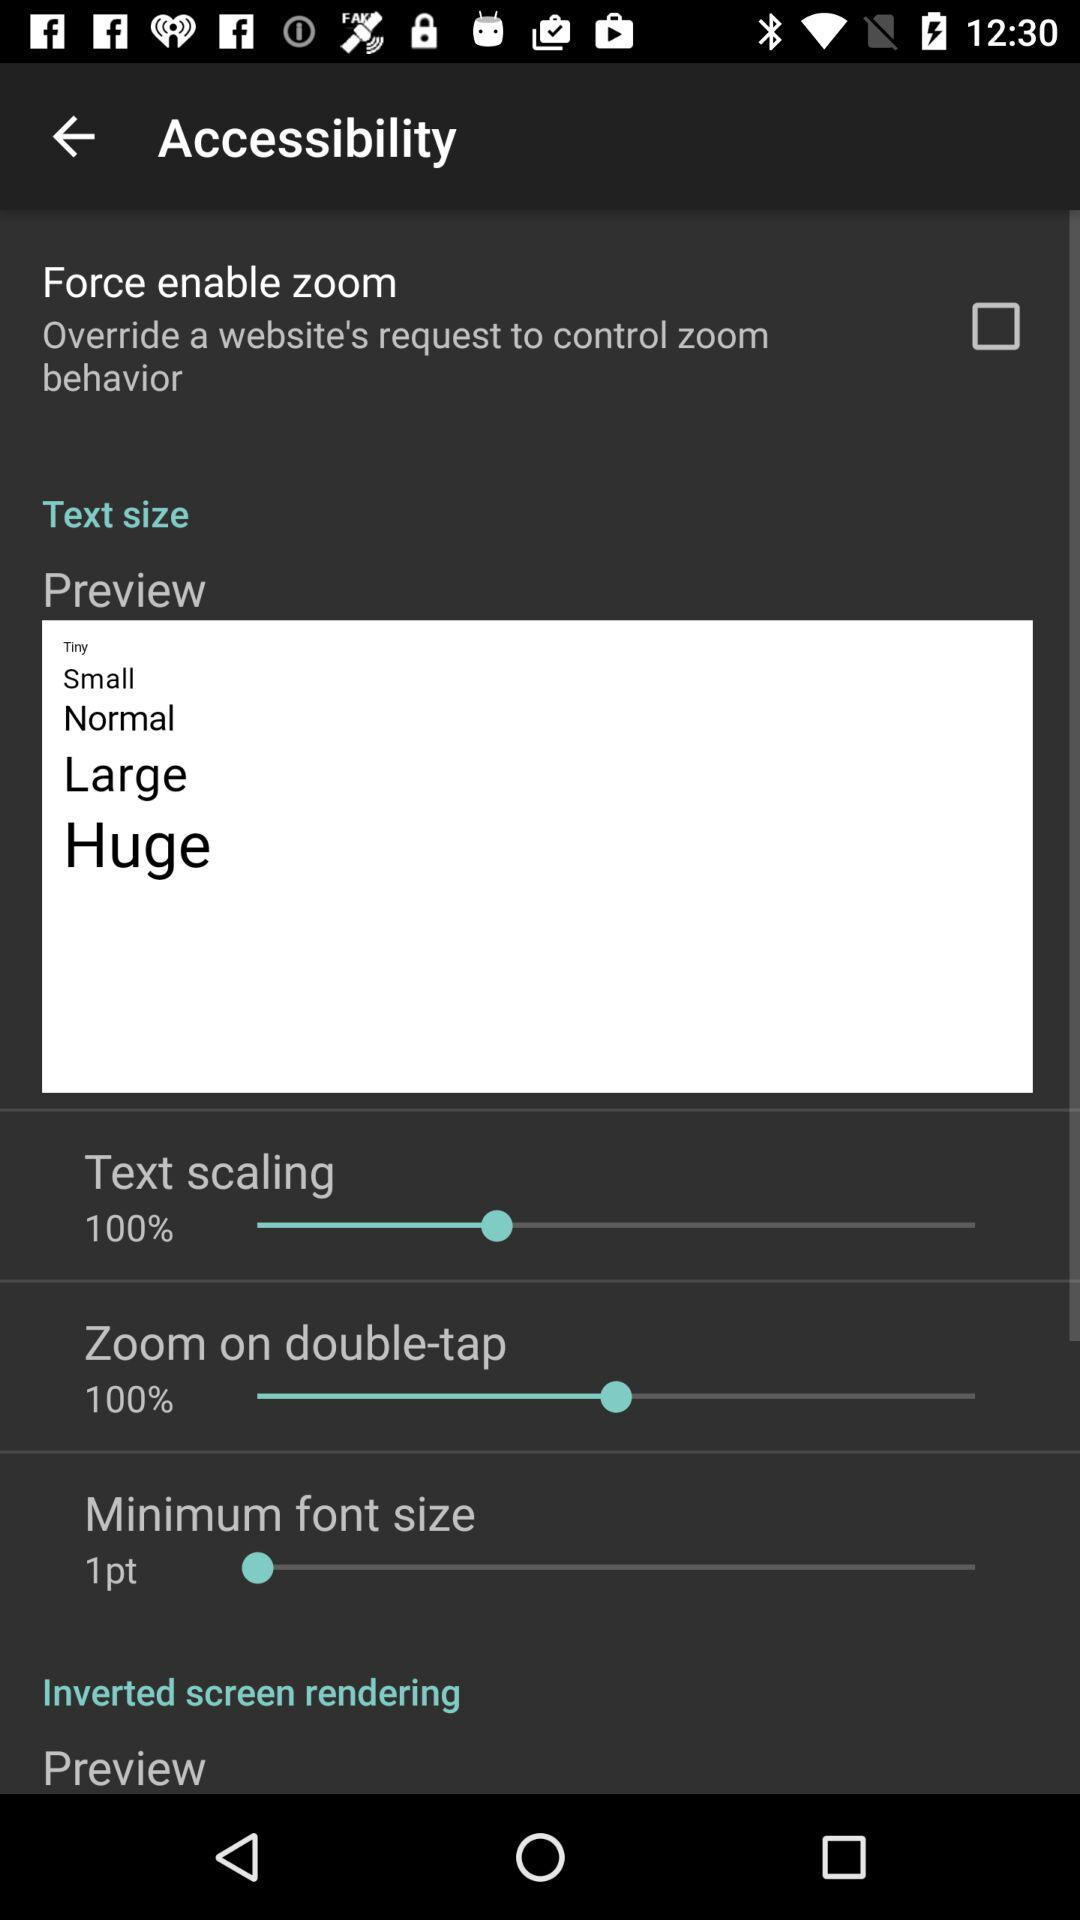What is the minimum font size? The minimum font size is 1 point. 